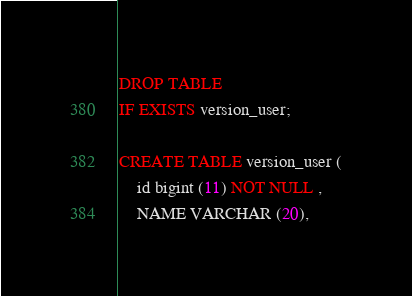<code> <loc_0><loc_0><loc_500><loc_500><_SQL_>DROP TABLE
IF EXISTS version_user;

CREATE TABLE version_user (
	id bigint (11) NOT NULL ,
	NAME VARCHAR (20),</code> 